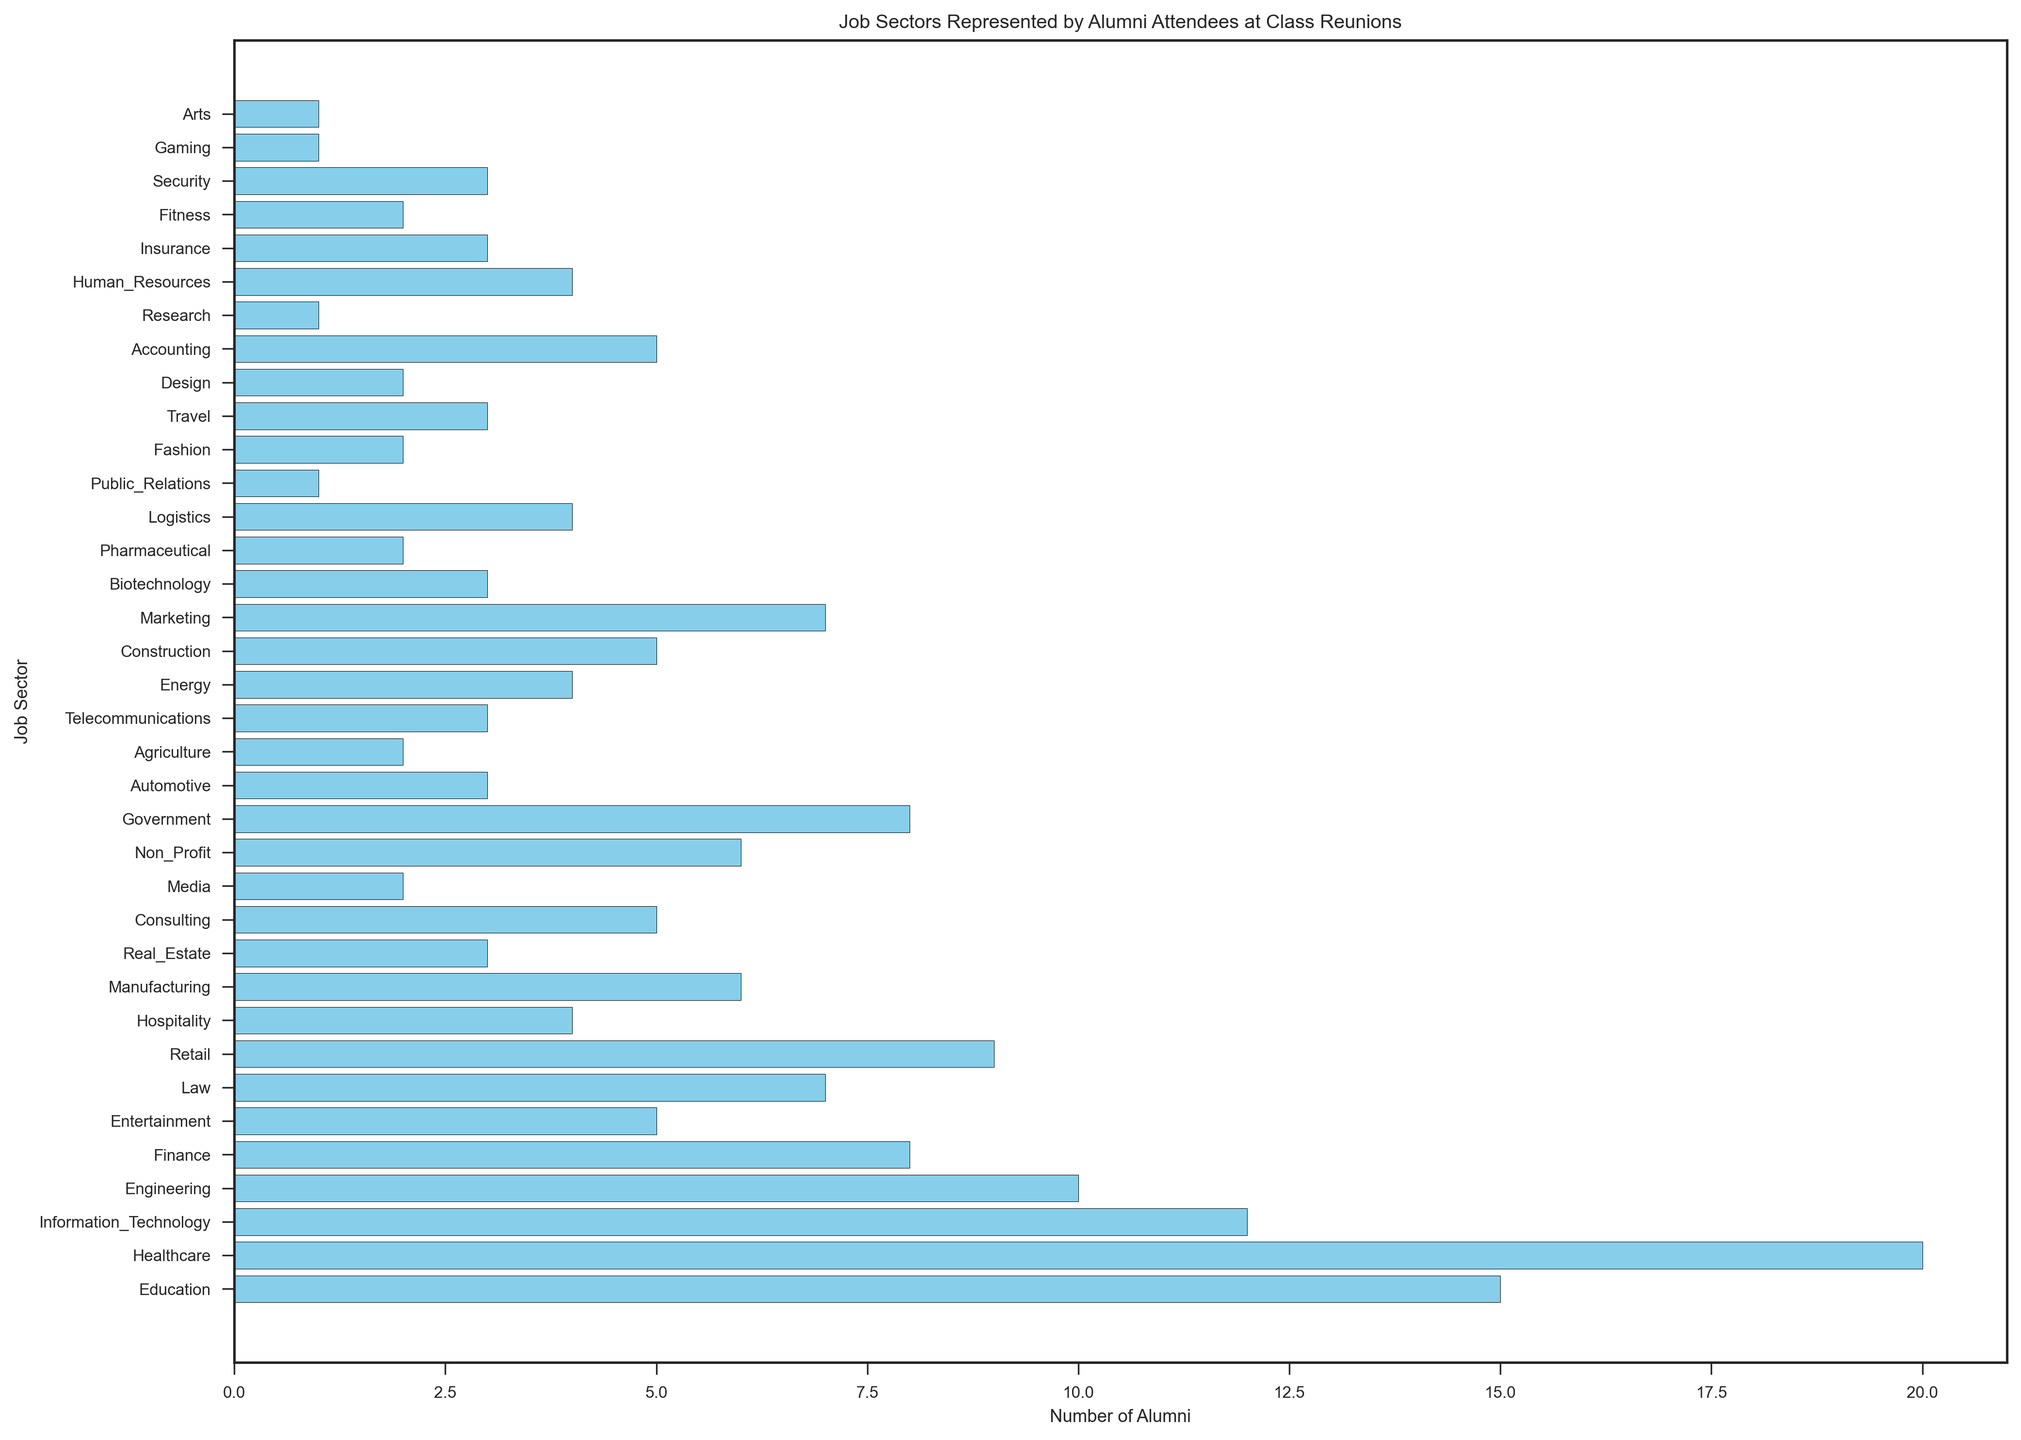What is the job sector with the highest number of alumni attendees at the class reunions? Look at the bar with the greatest length, which corresponds to the highest number. The Healthcare sector has the tallest bar, indicating it has the most alumni attendees.
Answer: Healthcare How many more alumni are in the Healthcare sector compared to the Education sector? Check the values for the Healthcare and Education sectors. Healthcare has 20 alumni and Education has 15. Subtracting these gives 20 - 15 = 5.
Answer: 5 What are the total number of alumni in the Engineering, Finance, and Law sectors combined? Look at the values for each sector: Engineering has 10, Finance has 8, and Law has 7. Adding these gives 10 + 8 + 7 = 25.
Answer: 25 Which sector has more alumni: Retail or Hospitality? Compare the bar lengths for Retail and Hospitality. Retail has 9 alumni, and Hospitality has 4. Thus, Retail has more alumni.
Answer: Retail What is the average number of alumni in the Non-Profit, Government, and Energy sectors? Check the values: Non-Profit has 6, Government has 8, and Energy has 4. Sum these values and divide by 3: (6 + 8 + 4) / 3 = 18 / 3 = 6.
Answer: 6 Are there more alumni in the Information Technology sector or the combined sectors of Real Estate and Logistics? Compare the number of alumni: Information Technology has 12. Real Estate and Logistics combined have 3 + 4 = 7. Thus, Information Technology has more alumni.
Answer: Information Technology Which sectors have an equal number of alumni attendees? Find sectors with the same height bars. Construction, Entertainment, Consulting, and Accounting all have 5 alumni each.
Answer: Construction, Entertainment, Consulting, and Accounting What is the median number of alumni across all the job sectors? List all sectors by the number of alumni: [1, 1, 1, 2, 2, 2, 2, 3, 3, 3, 3, 4, 4, 4, 4, 5, 5, 5, 5, 5, 6, 6, 6, 7, 7, 8, 8, 9, 10, 12, 15, 20]. With 32 values, the median is the average of the 16th and 17th values, both are 5. So, the median is (5+5)/2 = 5.
Answer: 5 How many alumni are there in total across all job sectors? Sum all the alumni numbers: 15 + 20 + 12 + 10 + 8 + 5 + 7 + 9 + 4 + 6 + 3 + 5 + 2 + 6 + 8 + 3 + 2 + 3 + 4 + 5 + 7 + 3 + 2 + 4 + 1 + 2 + 3 + 2 + 5 + 1 + 4 + 3 + 2 + 3 + 1 + 1 = 164.
Answer: 164 Which job sector has the smallest number of alumni attendees, and how many are there? Identify the bar with the shortest length. Public Relations, Research, Gaming, and Arts each have 1 alumni.
Answer: Public Relations, Research, Gaming, and Arts; 1 